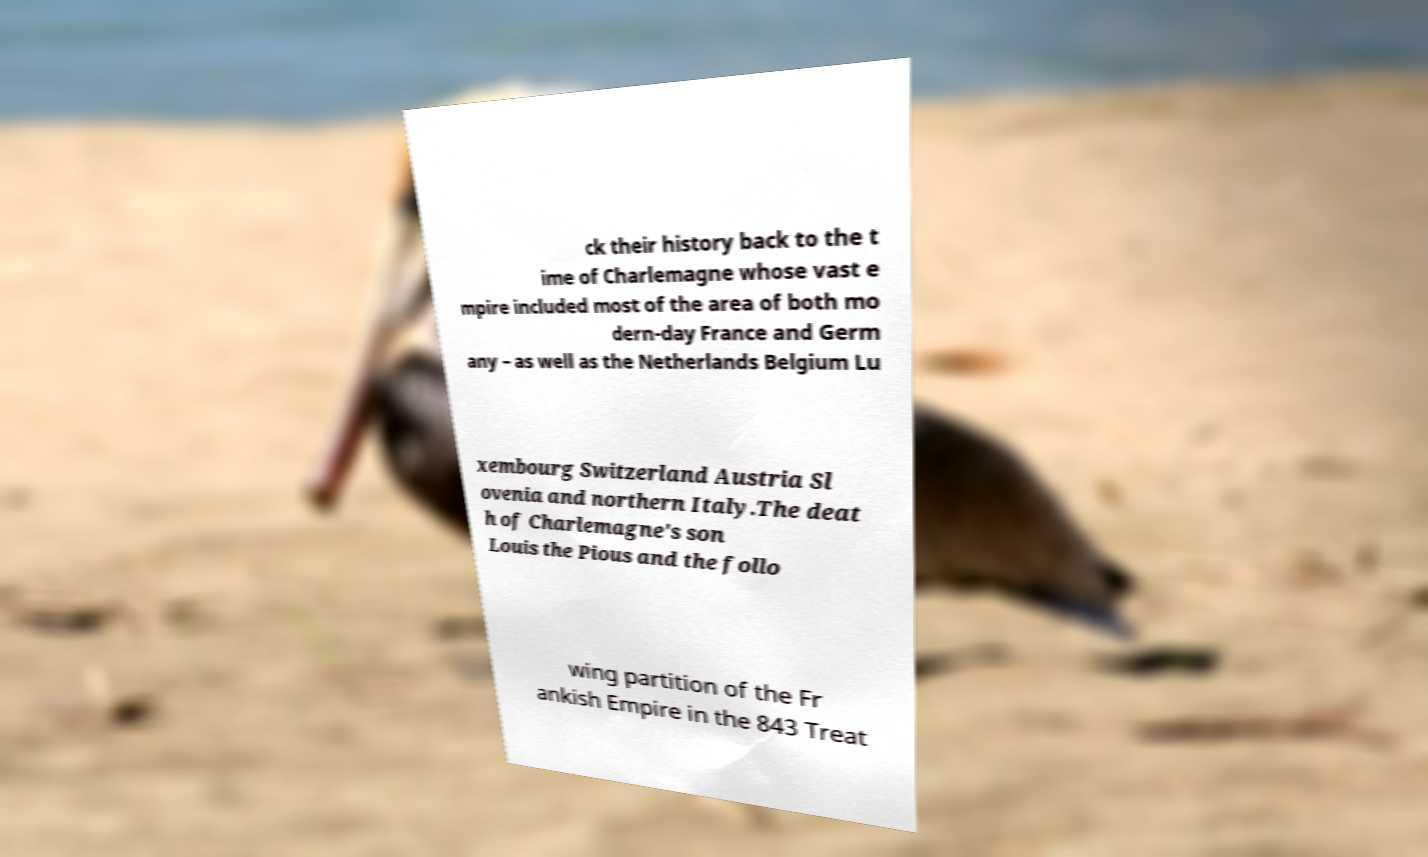Can you read and provide the text displayed in the image?This photo seems to have some interesting text. Can you extract and type it out for me? ck their history back to the t ime of Charlemagne whose vast e mpire included most of the area of both mo dern-day France and Germ any – as well as the Netherlands Belgium Lu xembourg Switzerland Austria Sl ovenia and northern Italy.The deat h of Charlemagne's son Louis the Pious and the follo wing partition of the Fr ankish Empire in the 843 Treat 